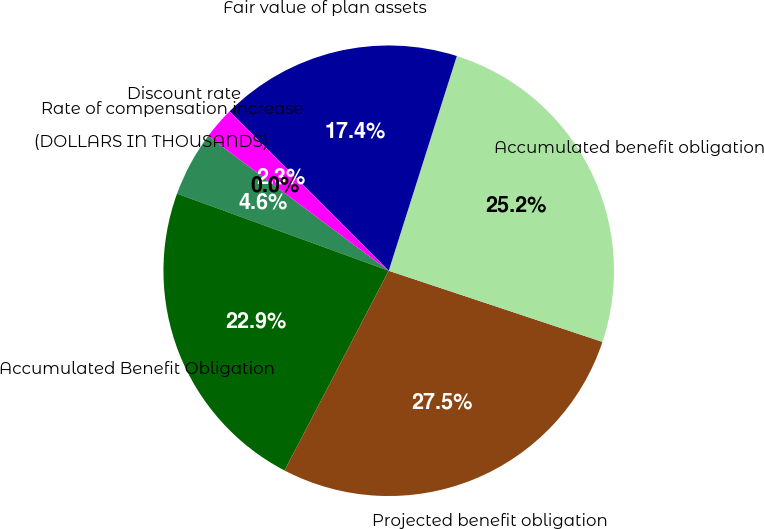Convert chart to OTSL. <chart><loc_0><loc_0><loc_500><loc_500><pie_chart><fcel>(DOLLARS IN THOUSANDS)<fcel>Accumulated Benefit Obligation<fcel>Projected benefit obligation<fcel>Accumulated benefit obligation<fcel>Fair value of plan assets<fcel>Discount rate<fcel>Rate of compensation increase<nl><fcel>4.64%<fcel>22.91%<fcel>27.54%<fcel>25.23%<fcel>17.37%<fcel>2.32%<fcel>0.0%<nl></chart> 